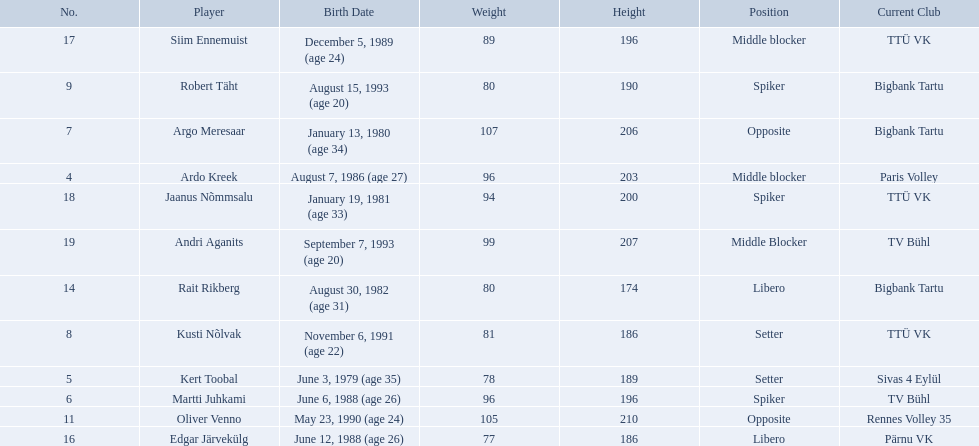What are the heights in cm of the men on the team? 203, 189, 196, 206, 186, 190, 210, 174, 186, 196, 200, 207. What is the tallest height of a team member? 210. Which player stands at 210? Oliver Venno. 